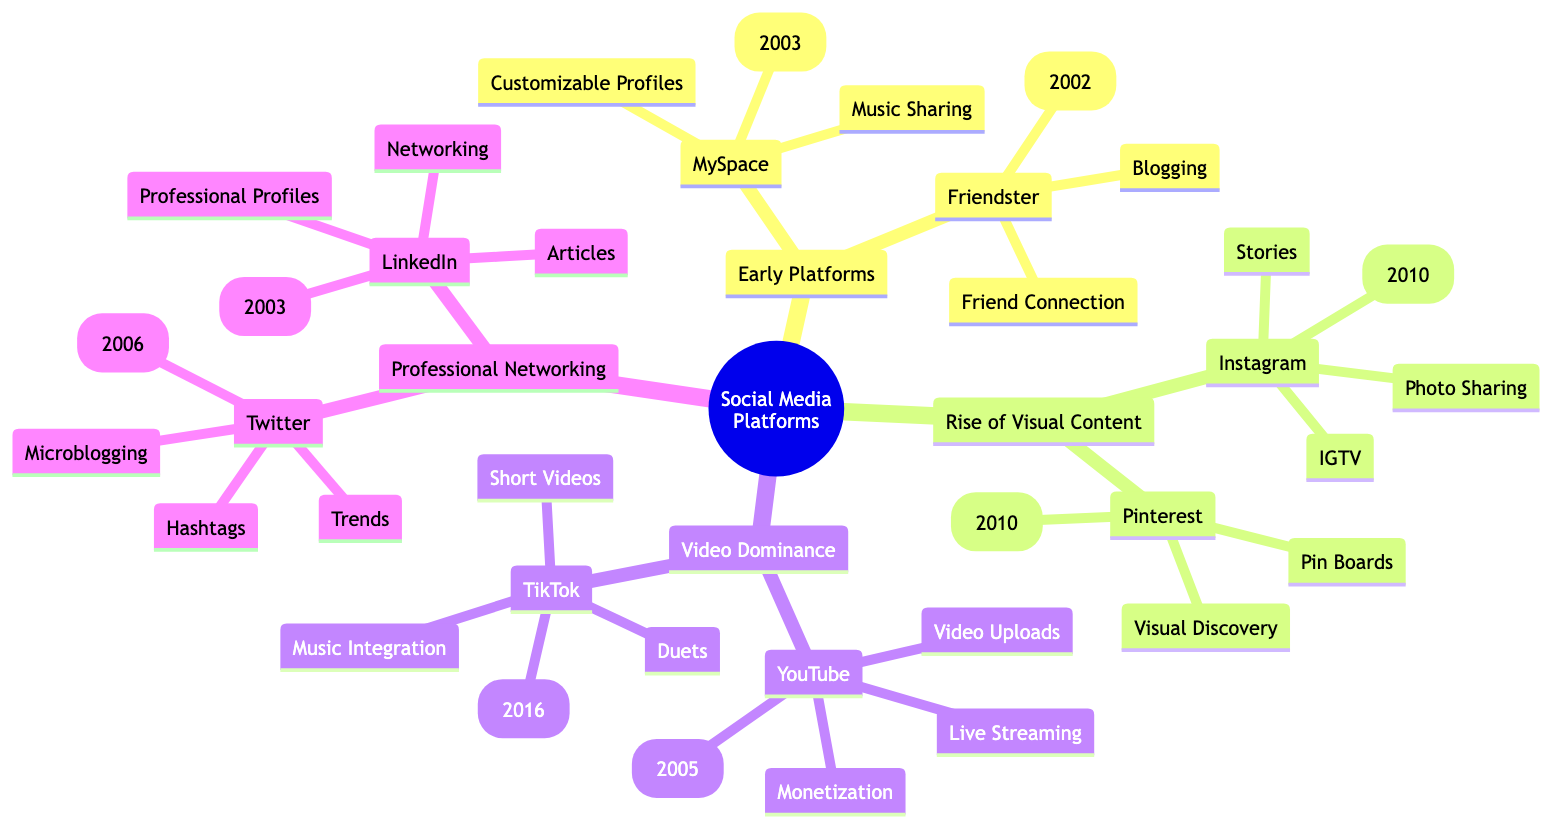What year was MySpace launched? The diagram indicates that MySpace is listed under "Early Platforms" with the corresponding year noted as 2003. Therefore, upon reviewing the information, we find that MySpace was launched in 2003.
Answer: 2003 Which platform is known for "Short Videos"? The diagram categorizes TikTok under "Video Dominance," highlighting its key feature of short videos. Hence, the answer is straightforward as TikTok is recognized for "Short Videos."
Answer: TikTok How many platforms are in the "Rise of Visual Content" category? In the diagram, the "Rise of Visual Content" section lists two platforms: Instagram and Pinterest. By counting these entries, we can conclude that there are two platforms in this category.
Answer: 2 What are the influencer features of LinkedIn? The diagram shows LinkedIn under "Professional Networking" with its influencer features listed as "Professional Profiles," "Articles," and "Networking." To answer the question, we can directly reference these features.
Answer: Professional Profiles, Articles, Networking Which platform was launched in 2006? The diagram indicates that Twitter is listed as launched in 2006 under the "Professional Networking" section. By locating the launch year in the respective area, we establish that Twitter was launched in 2006.
Answer: Twitter What type of content does Instagram primarily focus on? The diagram outlines that Instagram's features include "Photo Sharing," indicating that its primary focus is on sharing photos. Therefore, the answer revolves around Instagram's core content type.
Answer: Photo Sharing Which platform offers "Monetization" as an influencer feature? The diagram specifies YouTube under the "Video Dominance" category, with "Monetization" included in its set of influencer features. This leads us to conclude that YouTube is the platform that offers monetization.
Answer: YouTube Name one influencer feature of Pinterest. Looking at the diagram, Pinterest is highlighted under "Rise of Visual Content," with features such as "Pin Boards" and "Visual Discovery." Thus, we can state any of these as one feature of Pinterest.
Answer: Pin Boards 